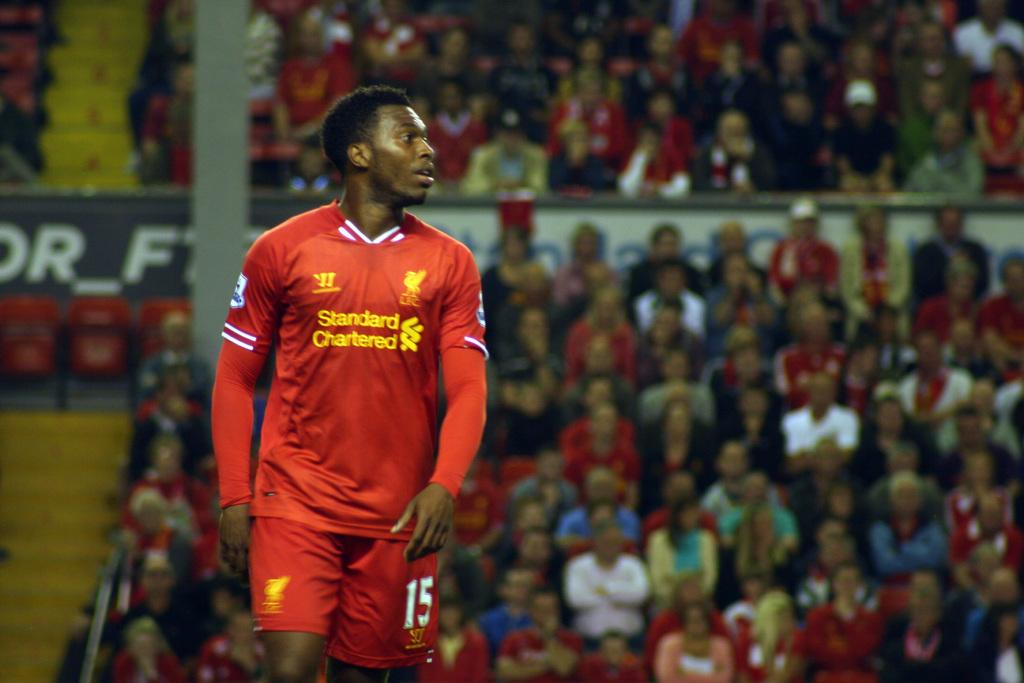<image>
Write a terse but informative summary of the picture. An athlete is wearing a sweatshirt that says Standard Chartered on it. 